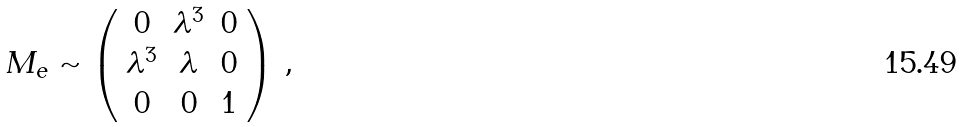Convert formula to latex. <formula><loc_0><loc_0><loc_500><loc_500>M _ { e } \sim \left ( \begin{array} { c c c } 0 & \lambda ^ { 3 } & 0 \\ \lambda ^ { 3 } & \lambda & 0 \\ 0 & 0 & 1 \\ \end{array} \right ) \, ,</formula> 